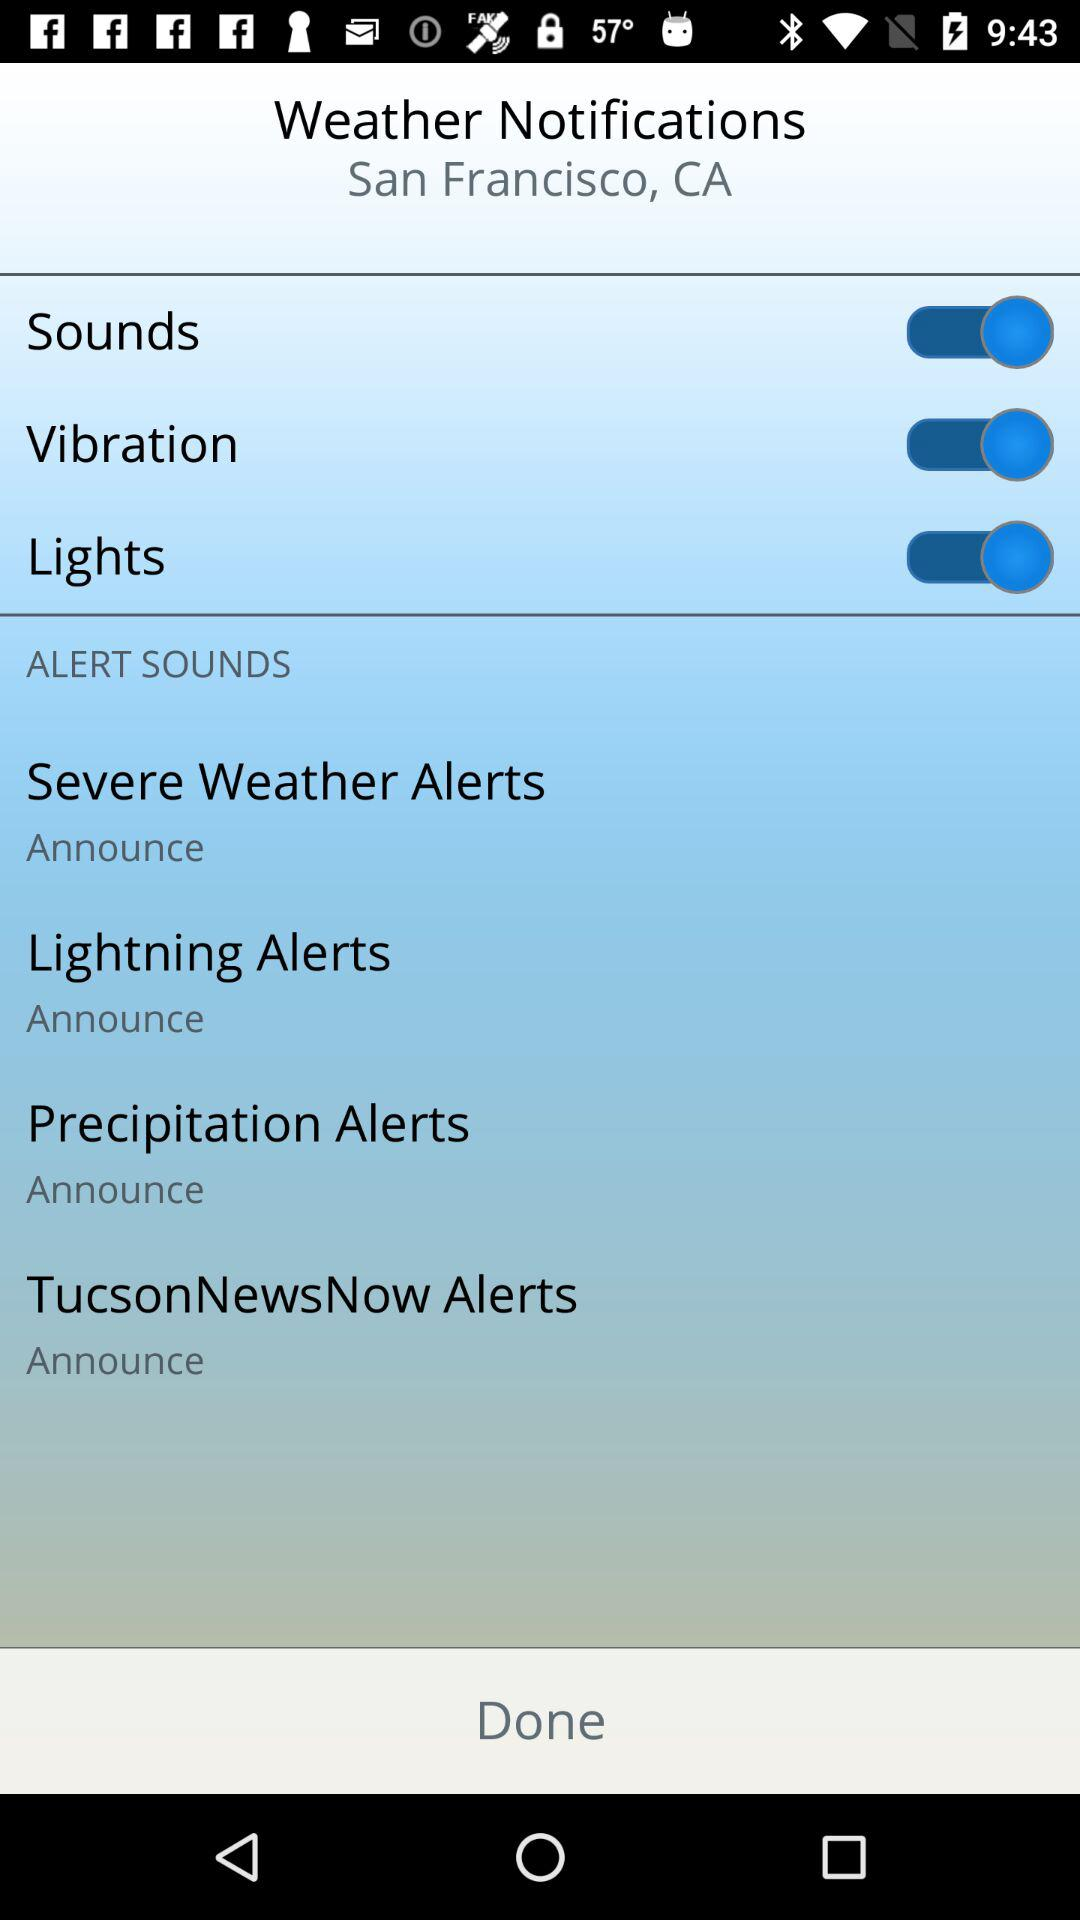What is the status of the "Vibration" notification setting? The status of the "Vibration" notification setting is "on". 